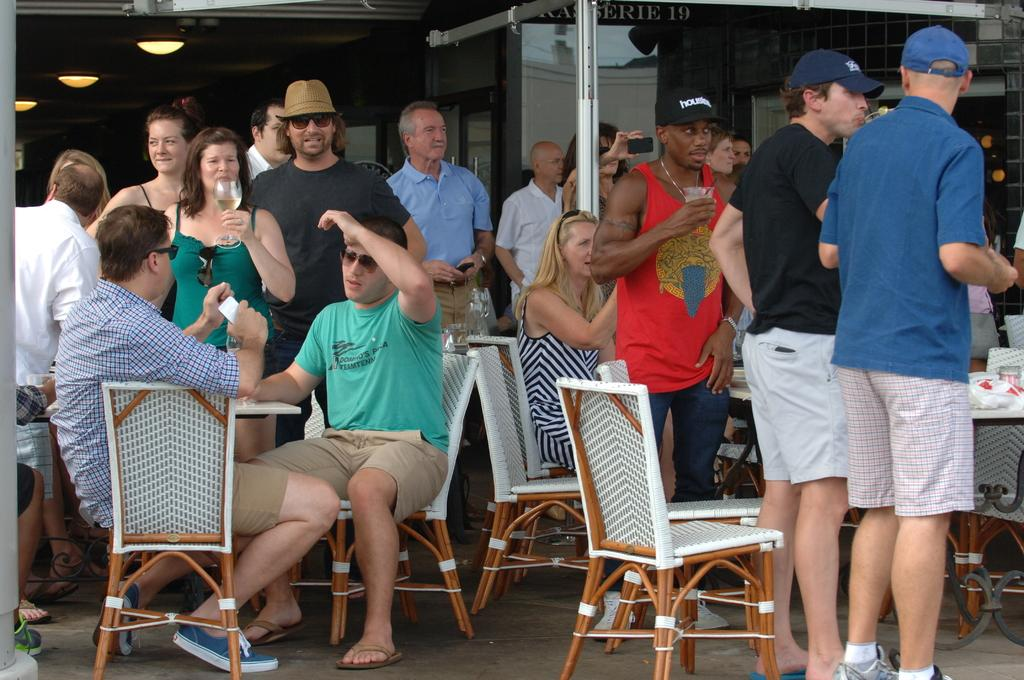What are the people in the image doing? There are people sitting on chairs and standing in the image. What are the people holding in their hands? The people are holding wine glasses in their hands. What type of berry can be seen growing on the man's head in the image? There is no man or berry present in the image. 